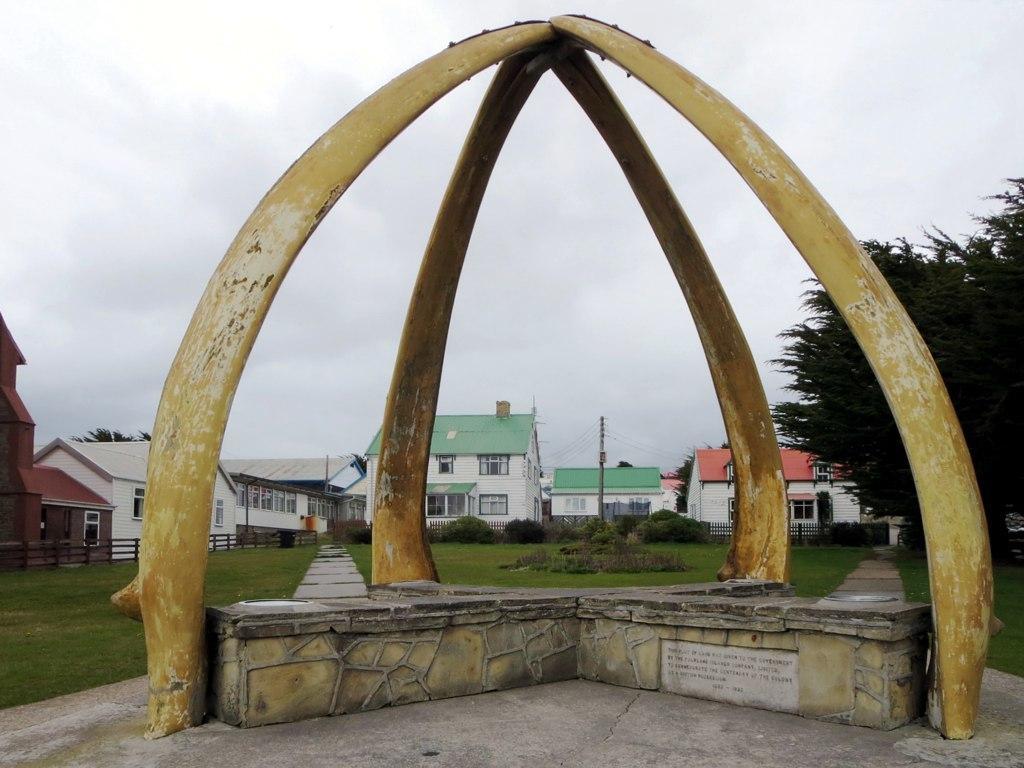Please provide a concise description of this image. In front of the image there are pillars and also there are small walls on the ground. On the wall there is a stone plate with something written on it. Behind them in the background there is grass on the ground. And also there are small plants. Behind them there is fencing. Behind the fencing there are buildings with walls, roofs and windows. At the top of the image there is sky. 